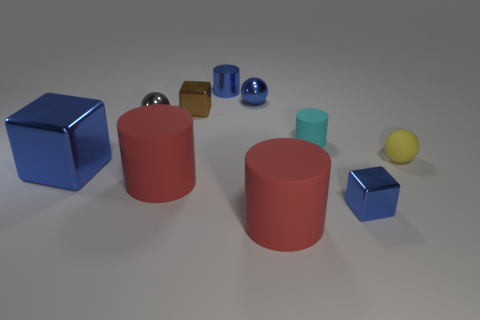Subtract all purple blocks. How many red cylinders are left? 2 Subtract all matte cylinders. How many cylinders are left? 1 Subtract all cylinders. How many objects are left? 6 Subtract 3 cylinders. How many cylinders are left? 1 Subtract all blue cylinders. How many cylinders are left? 3 Add 5 red matte things. How many red matte things exist? 7 Subtract 0 purple blocks. How many objects are left? 10 Subtract all green cubes. Subtract all gray balls. How many cubes are left? 3 Subtract all tiny blue metal cylinders. Subtract all tiny yellow rubber balls. How many objects are left? 8 Add 1 blue shiny spheres. How many blue shiny spheres are left? 2 